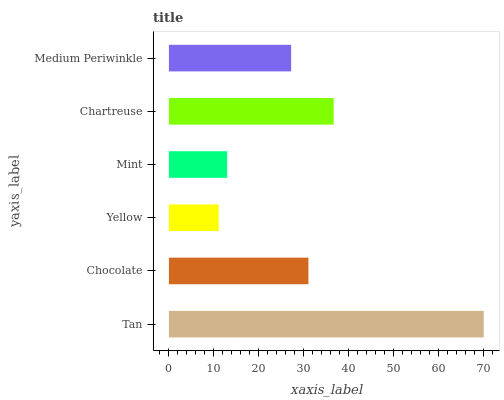Is Yellow the minimum?
Answer yes or no. Yes. Is Tan the maximum?
Answer yes or no. Yes. Is Chocolate the minimum?
Answer yes or no. No. Is Chocolate the maximum?
Answer yes or no. No. Is Tan greater than Chocolate?
Answer yes or no. Yes. Is Chocolate less than Tan?
Answer yes or no. Yes. Is Chocolate greater than Tan?
Answer yes or no. No. Is Tan less than Chocolate?
Answer yes or no. No. Is Chocolate the high median?
Answer yes or no. Yes. Is Medium Periwinkle the low median?
Answer yes or no. Yes. Is Chartreuse the high median?
Answer yes or no. No. Is Mint the low median?
Answer yes or no. No. 